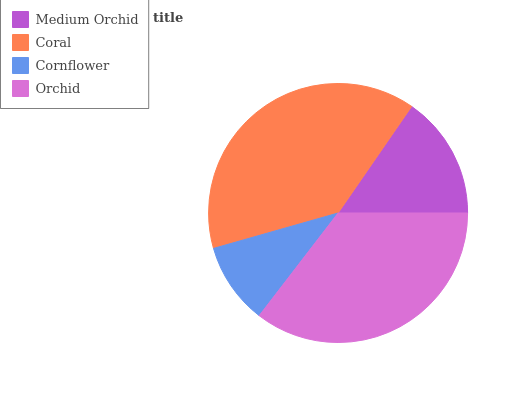Is Cornflower the minimum?
Answer yes or no. Yes. Is Coral the maximum?
Answer yes or no. Yes. Is Coral the minimum?
Answer yes or no. No. Is Cornflower the maximum?
Answer yes or no. No. Is Coral greater than Cornflower?
Answer yes or no. Yes. Is Cornflower less than Coral?
Answer yes or no. Yes. Is Cornflower greater than Coral?
Answer yes or no. No. Is Coral less than Cornflower?
Answer yes or no. No. Is Orchid the high median?
Answer yes or no. Yes. Is Medium Orchid the low median?
Answer yes or no. Yes. Is Coral the high median?
Answer yes or no. No. Is Orchid the low median?
Answer yes or no. No. 